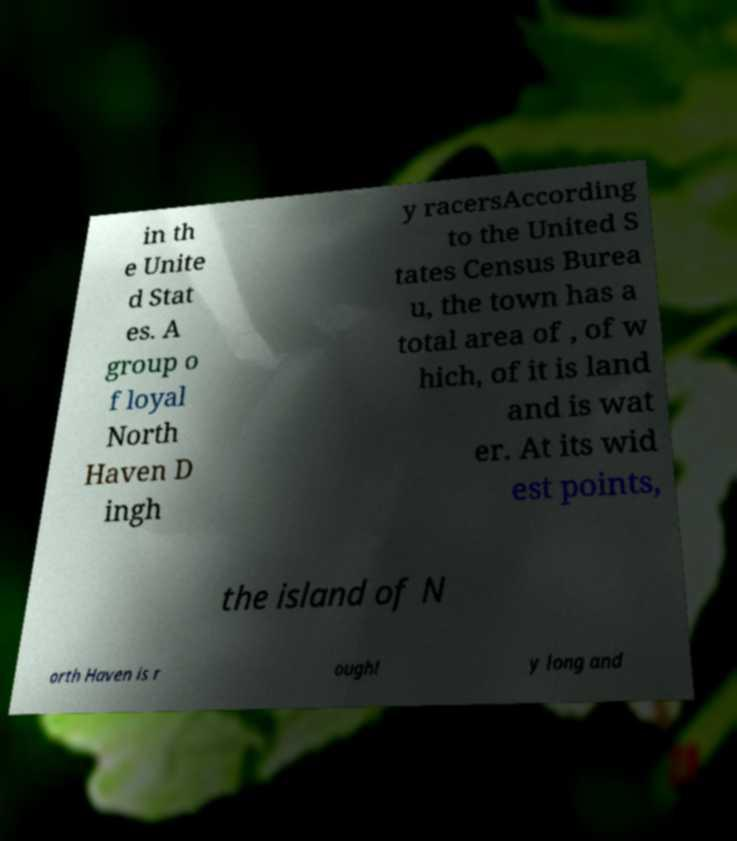What messages or text are displayed in this image? I need them in a readable, typed format. in th e Unite d Stat es. A group o f loyal North Haven D ingh y racersAccording to the United S tates Census Burea u, the town has a total area of , of w hich, of it is land and is wat er. At its wid est points, the island of N orth Haven is r oughl y long and 